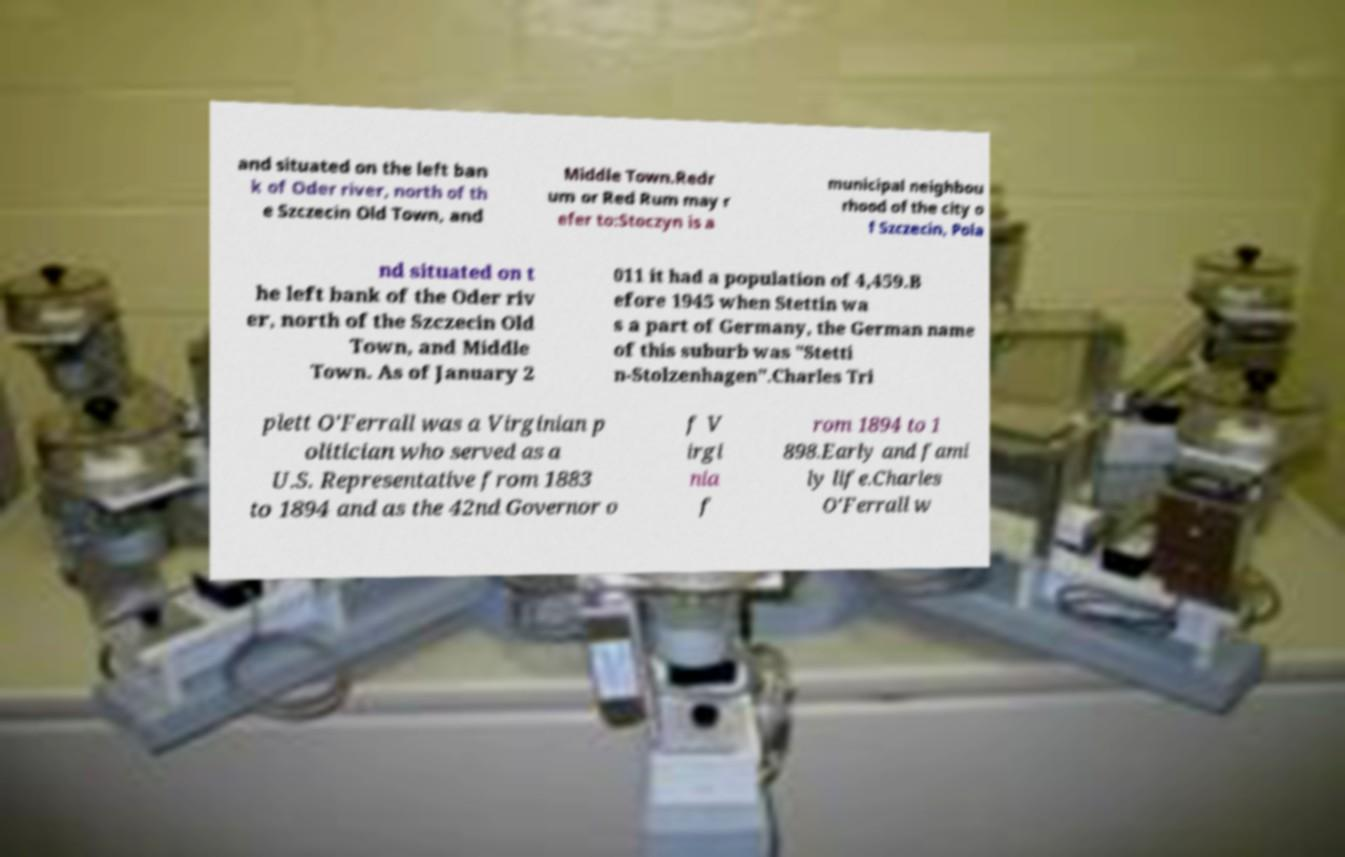Can you read and provide the text displayed in the image?This photo seems to have some interesting text. Can you extract and type it out for me? and situated on the left ban k of Oder river, north of th e Szczecin Old Town, and Middle Town.Redr um or Red Rum may r efer to:Stoczyn is a municipal neighbou rhood of the city o f Szczecin, Pola nd situated on t he left bank of the Oder riv er, north of the Szczecin Old Town, and Middle Town. As of January 2 011 it had a population of 4,459.B efore 1945 when Stettin wa s a part of Germany, the German name of this suburb was "Stetti n-Stolzenhagen".Charles Tri plett O'Ferrall was a Virginian p olitician who served as a U.S. Representative from 1883 to 1894 and as the 42nd Governor o f V irgi nia f rom 1894 to 1 898.Early and fami ly life.Charles O'Ferrall w 